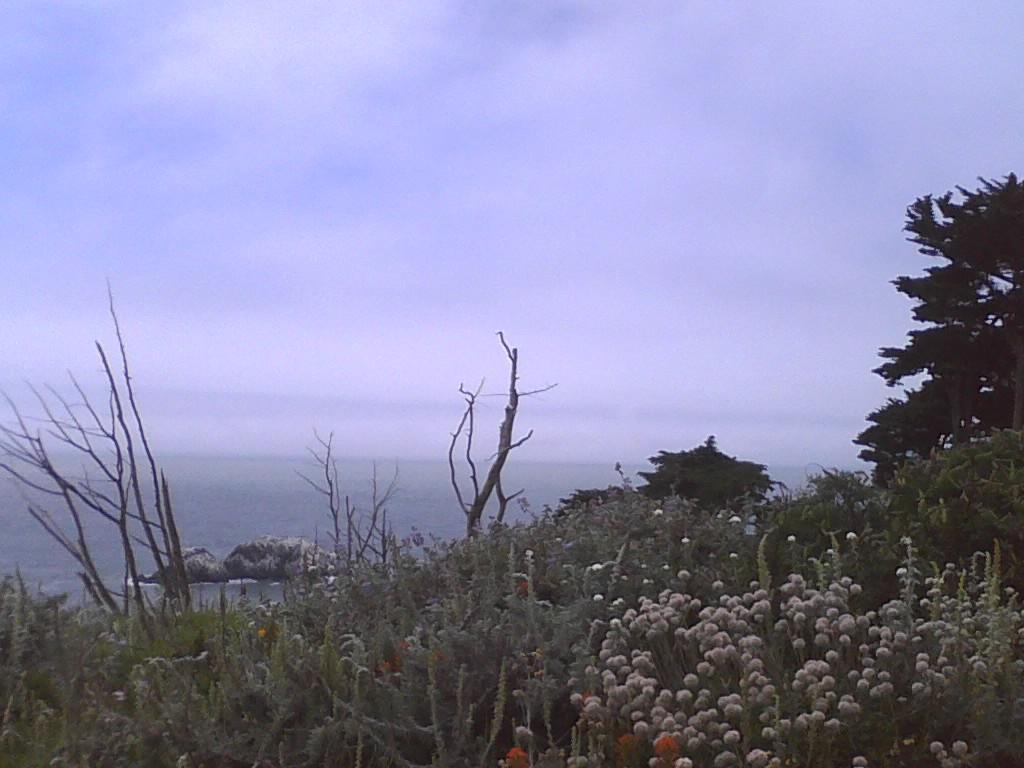What type of vegetation is on the ground in the image? There are plants on the ground in the image. Are there any specific features of the plants? Some of the plants have flowers. What can be seen in the background of the image? There are trees and water visible in the background. What is the color of the sky in the image? The sky is blue in the image. Are there any weather conditions visible in the sky? Yes, there are clouds in the sky. How many cakes are being sold by the slave in the image? There is no slave or cakes present in the image. What is the value of the dime found near the plants in the image? There is no dime present in the image. 